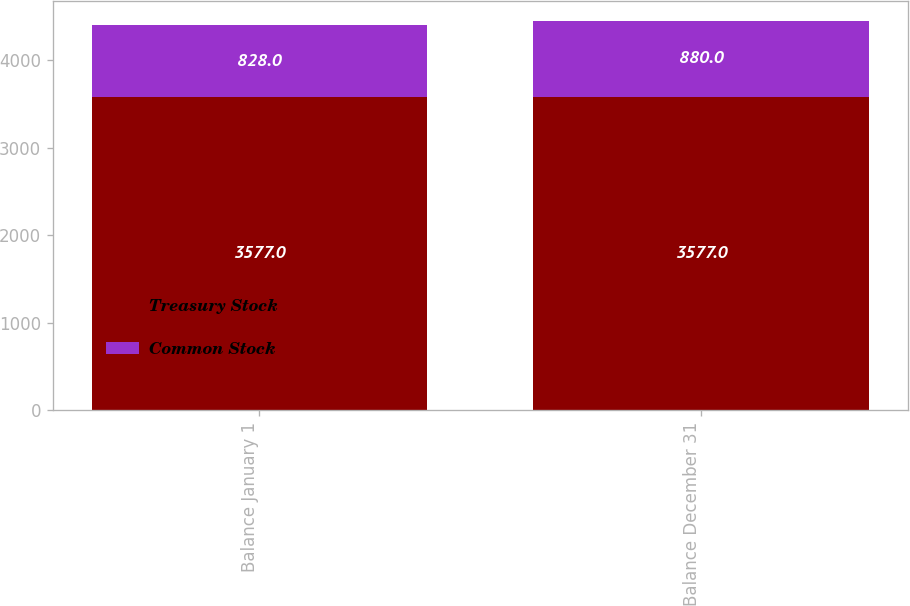Convert chart to OTSL. <chart><loc_0><loc_0><loc_500><loc_500><stacked_bar_chart><ecel><fcel>Balance January 1<fcel>Balance December 31<nl><fcel>Treasury Stock<fcel>3577<fcel>3577<nl><fcel>Common Stock<fcel>828<fcel>880<nl></chart> 